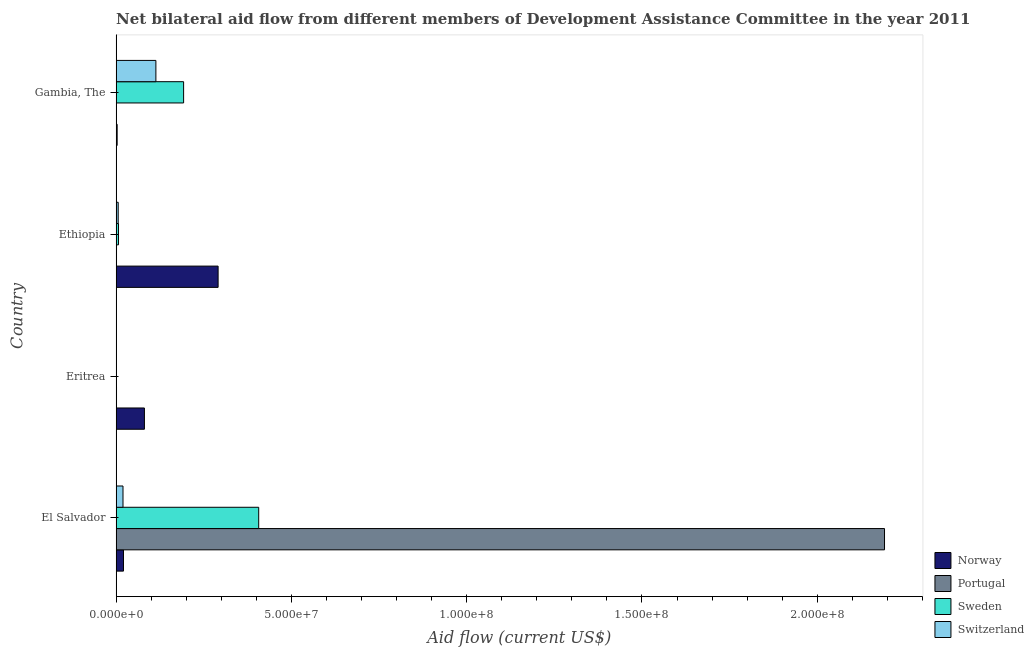Are the number of bars on each tick of the Y-axis equal?
Your response must be concise. Yes. How many bars are there on the 3rd tick from the top?
Offer a terse response. 4. How many bars are there on the 2nd tick from the bottom?
Offer a terse response. 4. What is the label of the 3rd group of bars from the top?
Offer a terse response. Eritrea. In how many cases, is the number of bars for a given country not equal to the number of legend labels?
Offer a terse response. 0. What is the amount of aid given by sweden in El Salvador?
Make the answer very short. 4.07e+07. Across all countries, what is the maximum amount of aid given by sweden?
Give a very brief answer. 4.07e+07. Across all countries, what is the minimum amount of aid given by switzerland?
Your answer should be very brief. 6.00e+04. In which country was the amount of aid given by switzerland maximum?
Offer a terse response. Gambia, The. In which country was the amount of aid given by switzerland minimum?
Your response must be concise. Eritrea. What is the total amount of aid given by norway in the graph?
Your answer should be compact. 3.96e+07. What is the difference between the amount of aid given by sweden in El Salvador and that in Gambia, The?
Provide a short and direct response. 2.14e+07. What is the difference between the amount of aid given by norway in Eritrea and the amount of aid given by portugal in El Salvador?
Offer a terse response. -2.11e+08. What is the average amount of aid given by switzerland per country?
Provide a succinct answer. 3.49e+06. What is the difference between the amount of aid given by sweden and amount of aid given by portugal in Ethiopia?
Your response must be concise. 5.70e+05. In how many countries, is the amount of aid given by portugal greater than 20000000 US$?
Provide a succinct answer. 1. What is the ratio of the amount of aid given by sweden in Eritrea to that in Gambia, The?
Offer a very short reply. 0. What is the difference between the highest and the second highest amount of aid given by switzerland?
Provide a succinct answer. 9.38e+06. What is the difference between the highest and the lowest amount of aid given by portugal?
Offer a terse response. 2.19e+08. In how many countries, is the amount of aid given by portugal greater than the average amount of aid given by portugal taken over all countries?
Offer a terse response. 1. Is the sum of the amount of aid given by portugal in Eritrea and Ethiopia greater than the maximum amount of aid given by switzerland across all countries?
Offer a very short reply. No. Is it the case that in every country, the sum of the amount of aid given by norway and amount of aid given by portugal is greater than the sum of amount of aid given by switzerland and amount of aid given by sweden?
Your answer should be compact. No. What does the 2nd bar from the bottom in El Salvador represents?
Ensure brevity in your answer.  Portugal. Is it the case that in every country, the sum of the amount of aid given by norway and amount of aid given by portugal is greater than the amount of aid given by sweden?
Keep it short and to the point. No. How many bars are there?
Your response must be concise. 16. Are all the bars in the graph horizontal?
Your response must be concise. Yes. Are the values on the major ticks of X-axis written in scientific E-notation?
Make the answer very short. Yes. Does the graph contain any zero values?
Offer a very short reply. No. Does the graph contain grids?
Offer a terse response. No. How many legend labels are there?
Your answer should be very brief. 4. How are the legend labels stacked?
Ensure brevity in your answer.  Vertical. What is the title of the graph?
Ensure brevity in your answer.  Net bilateral aid flow from different members of Development Assistance Committee in the year 2011. Does "Revenue mobilization" appear as one of the legend labels in the graph?
Your answer should be very brief. No. What is the label or title of the X-axis?
Provide a short and direct response. Aid flow (current US$). What is the label or title of the Y-axis?
Keep it short and to the point. Country. What is the Aid flow (current US$) in Norway in El Salvador?
Keep it short and to the point. 2.10e+06. What is the Aid flow (current US$) in Portugal in El Salvador?
Provide a short and direct response. 2.19e+08. What is the Aid flow (current US$) of Sweden in El Salvador?
Provide a succinct answer. 4.07e+07. What is the Aid flow (current US$) of Switzerland in El Salvador?
Provide a succinct answer. 1.96e+06. What is the Aid flow (current US$) of Norway in Eritrea?
Provide a succinct answer. 8.07e+06. What is the Aid flow (current US$) in Portugal in Eritrea?
Provide a short and direct response. 1.10e+05. What is the Aid flow (current US$) in Norway in Ethiopia?
Your response must be concise. 2.91e+07. What is the Aid flow (current US$) in Portugal in Ethiopia?
Your response must be concise. 1.10e+05. What is the Aid flow (current US$) in Sweden in Ethiopia?
Give a very brief answer. 6.80e+05. What is the Aid flow (current US$) in Switzerland in Ethiopia?
Offer a very short reply. 5.90e+05. What is the Aid flow (current US$) of Portugal in Gambia, The?
Your response must be concise. 2.00e+04. What is the Aid flow (current US$) of Sweden in Gambia, The?
Provide a short and direct response. 1.92e+07. What is the Aid flow (current US$) of Switzerland in Gambia, The?
Offer a terse response. 1.13e+07. Across all countries, what is the maximum Aid flow (current US$) of Norway?
Keep it short and to the point. 2.91e+07. Across all countries, what is the maximum Aid flow (current US$) of Portugal?
Your response must be concise. 2.19e+08. Across all countries, what is the maximum Aid flow (current US$) in Sweden?
Offer a terse response. 4.07e+07. Across all countries, what is the maximum Aid flow (current US$) in Switzerland?
Keep it short and to the point. 1.13e+07. Across all countries, what is the minimum Aid flow (current US$) of Sweden?
Ensure brevity in your answer.  6.00e+04. Across all countries, what is the minimum Aid flow (current US$) in Switzerland?
Offer a very short reply. 6.00e+04. What is the total Aid flow (current US$) of Norway in the graph?
Ensure brevity in your answer.  3.96e+07. What is the total Aid flow (current US$) in Portugal in the graph?
Provide a succinct answer. 2.19e+08. What is the total Aid flow (current US$) of Sweden in the graph?
Your response must be concise. 6.07e+07. What is the total Aid flow (current US$) in Switzerland in the graph?
Your answer should be compact. 1.40e+07. What is the difference between the Aid flow (current US$) of Norway in El Salvador and that in Eritrea?
Your response must be concise. -5.97e+06. What is the difference between the Aid flow (current US$) in Portugal in El Salvador and that in Eritrea?
Make the answer very short. 2.19e+08. What is the difference between the Aid flow (current US$) in Sweden in El Salvador and that in Eritrea?
Offer a terse response. 4.06e+07. What is the difference between the Aid flow (current US$) in Switzerland in El Salvador and that in Eritrea?
Make the answer very short. 1.90e+06. What is the difference between the Aid flow (current US$) of Norway in El Salvador and that in Ethiopia?
Provide a short and direct response. -2.70e+07. What is the difference between the Aid flow (current US$) in Portugal in El Salvador and that in Ethiopia?
Offer a very short reply. 2.19e+08. What is the difference between the Aid flow (current US$) of Sweden in El Salvador and that in Ethiopia?
Offer a terse response. 4.00e+07. What is the difference between the Aid flow (current US$) in Switzerland in El Salvador and that in Ethiopia?
Your answer should be very brief. 1.37e+06. What is the difference between the Aid flow (current US$) in Norway in El Salvador and that in Gambia, The?
Offer a very short reply. 1.81e+06. What is the difference between the Aid flow (current US$) in Portugal in El Salvador and that in Gambia, The?
Your answer should be compact. 2.19e+08. What is the difference between the Aid flow (current US$) in Sweden in El Salvador and that in Gambia, The?
Offer a terse response. 2.14e+07. What is the difference between the Aid flow (current US$) of Switzerland in El Salvador and that in Gambia, The?
Provide a succinct answer. -9.38e+06. What is the difference between the Aid flow (current US$) in Norway in Eritrea and that in Ethiopia?
Keep it short and to the point. -2.10e+07. What is the difference between the Aid flow (current US$) in Sweden in Eritrea and that in Ethiopia?
Provide a short and direct response. -6.20e+05. What is the difference between the Aid flow (current US$) in Switzerland in Eritrea and that in Ethiopia?
Your answer should be very brief. -5.30e+05. What is the difference between the Aid flow (current US$) in Norway in Eritrea and that in Gambia, The?
Give a very brief answer. 7.78e+06. What is the difference between the Aid flow (current US$) in Portugal in Eritrea and that in Gambia, The?
Provide a short and direct response. 9.00e+04. What is the difference between the Aid flow (current US$) in Sweden in Eritrea and that in Gambia, The?
Provide a succinct answer. -1.92e+07. What is the difference between the Aid flow (current US$) in Switzerland in Eritrea and that in Gambia, The?
Your answer should be compact. -1.13e+07. What is the difference between the Aid flow (current US$) in Norway in Ethiopia and that in Gambia, The?
Give a very brief answer. 2.88e+07. What is the difference between the Aid flow (current US$) in Portugal in Ethiopia and that in Gambia, The?
Your answer should be very brief. 9.00e+04. What is the difference between the Aid flow (current US$) in Sweden in Ethiopia and that in Gambia, The?
Your response must be concise. -1.86e+07. What is the difference between the Aid flow (current US$) of Switzerland in Ethiopia and that in Gambia, The?
Provide a short and direct response. -1.08e+07. What is the difference between the Aid flow (current US$) in Norway in El Salvador and the Aid flow (current US$) in Portugal in Eritrea?
Offer a terse response. 1.99e+06. What is the difference between the Aid flow (current US$) of Norway in El Salvador and the Aid flow (current US$) of Sweden in Eritrea?
Keep it short and to the point. 2.04e+06. What is the difference between the Aid flow (current US$) of Norway in El Salvador and the Aid flow (current US$) of Switzerland in Eritrea?
Make the answer very short. 2.04e+06. What is the difference between the Aid flow (current US$) of Portugal in El Salvador and the Aid flow (current US$) of Sweden in Eritrea?
Your answer should be compact. 2.19e+08. What is the difference between the Aid flow (current US$) in Portugal in El Salvador and the Aid flow (current US$) in Switzerland in Eritrea?
Keep it short and to the point. 2.19e+08. What is the difference between the Aid flow (current US$) in Sweden in El Salvador and the Aid flow (current US$) in Switzerland in Eritrea?
Provide a short and direct response. 4.06e+07. What is the difference between the Aid flow (current US$) in Norway in El Salvador and the Aid flow (current US$) in Portugal in Ethiopia?
Ensure brevity in your answer.  1.99e+06. What is the difference between the Aid flow (current US$) in Norway in El Salvador and the Aid flow (current US$) in Sweden in Ethiopia?
Make the answer very short. 1.42e+06. What is the difference between the Aid flow (current US$) in Norway in El Salvador and the Aid flow (current US$) in Switzerland in Ethiopia?
Offer a very short reply. 1.51e+06. What is the difference between the Aid flow (current US$) of Portugal in El Salvador and the Aid flow (current US$) of Sweden in Ethiopia?
Give a very brief answer. 2.19e+08. What is the difference between the Aid flow (current US$) of Portugal in El Salvador and the Aid flow (current US$) of Switzerland in Ethiopia?
Provide a succinct answer. 2.19e+08. What is the difference between the Aid flow (current US$) in Sweden in El Salvador and the Aid flow (current US$) in Switzerland in Ethiopia?
Provide a short and direct response. 4.01e+07. What is the difference between the Aid flow (current US$) in Norway in El Salvador and the Aid flow (current US$) in Portugal in Gambia, The?
Your response must be concise. 2.08e+06. What is the difference between the Aid flow (current US$) of Norway in El Salvador and the Aid flow (current US$) of Sweden in Gambia, The?
Provide a succinct answer. -1.72e+07. What is the difference between the Aid flow (current US$) of Norway in El Salvador and the Aid flow (current US$) of Switzerland in Gambia, The?
Offer a very short reply. -9.24e+06. What is the difference between the Aid flow (current US$) in Portugal in El Salvador and the Aid flow (current US$) in Sweden in Gambia, The?
Offer a very short reply. 2.00e+08. What is the difference between the Aid flow (current US$) of Portugal in El Salvador and the Aid flow (current US$) of Switzerland in Gambia, The?
Keep it short and to the point. 2.08e+08. What is the difference between the Aid flow (current US$) of Sweden in El Salvador and the Aid flow (current US$) of Switzerland in Gambia, The?
Keep it short and to the point. 2.93e+07. What is the difference between the Aid flow (current US$) in Norway in Eritrea and the Aid flow (current US$) in Portugal in Ethiopia?
Your response must be concise. 7.96e+06. What is the difference between the Aid flow (current US$) of Norway in Eritrea and the Aid flow (current US$) of Sweden in Ethiopia?
Ensure brevity in your answer.  7.39e+06. What is the difference between the Aid flow (current US$) of Norway in Eritrea and the Aid flow (current US$) of Switzerland in Ethiopia?
Offer a terse response. 7.48e+06. What is the difference between the Aid flow (current US$) in Portugal in Eritrea and the Aid flow (current US$) in Sweden in Ethiopia?
Give a very brief answer. -5.70e+05. What is the difference between the Aid flow (current US$) in Portugal in Eritrea and the Aid flow (current US$) in Switzerland in Ethiopia?
Ensure brevity in your answer.  -4.80e+05. What is the difference between the Aid flow (current US$) of Sweden in Eritrea and the Aid flow (current US$) of Switzerland in Ethiopia?
Offer a very short reply. -5.30e+05. What is the difference between the Aid flow (current US$) of Norway in Eritrea and the Aid flow (current US$) of Portugal in Gambia, The?
Make the answer very short. 8.05e+06. What is the difference between the Aid flow (current US$) in Norway in Eritrea and the Aid flow (current US$) in Sweden in Gambia, The?
Keep it short and to the point. -1.12e+07. What is the difference between the Aid flow (current US$) in Norway in Eritrea and the Aid flow (current US$) in Switzerland in Gambia, The?
Provide a succinct answer. -3.27e+06. What is the difference between the Aid flow (current US$) of Portugal in Eritrea and the Aid flow (current US$) of Sweden in Gambia, The?
Offer a very short reply. -1.91e+07. What is the difference between the Aid flow (current US$) in Portugal in Eritrea and the Aid flow (current US$) in Switzerland in Gambia, The?
Offer a very short reply. -1.12e+07. What is the difference between the Aid flow (current US$) of Sweden in Eritrea and the Aid flow (current US$) of Switzerland in Gambia, The?
Your response must be concise. -1.13e+07. What is the difference between the Aid flow (current US$) of Norway in Ethiopia and the Aid flow (current US$) of Portugal in Gambia, The?
Give a very brief answer. 2.91e+07. What is the difference between the Aid flow (current US$) of Norway in Ethiopia and the Aid flow (current US$) of Sweden in Gambia, The?
Ensure brevity in your answer.  9.84e+06. What is the difference between the Aid flow (current US$) in Norway in Ethiopia and the Aid flow (current US$) in Switzerland in Gambia, The?
Provide a succinct answer. 1.78e+07. What is the difference between the Aid flow (current US$) in Portugal in Ethiopia and the Aid flow (current US$) in Sweden in Gambia, The?
Make the answer very short. -1.91e+07. What is the difference between the Aid flow (current US$) of Portugal in Ethiopia and the Aid flow (current US$) of Switzerland in Gambia, The?
Your answer should be compact. -1.12e+07. What is the difference between the Aid flow (current US$) in Sweden in Ethiopia and the Aid flow (current US$) in Switzerland in Gambia, The?
Provide a succinct answer. -1.07e+07. What is the average Aid flow (current US$) of Norway per country?
Offer a terse response. 9.89e+06. What is the average Aid flow (current US$) of Portugal per country?
Provide a short and direct response. 5.49e+07. What is the average Aid flow (current US$) of Sweden per country?
Offer a very short reply. 1.52e+07. What is the average Aid flow (current US$) of Switzerland per country?
Your response must be concise. 3.49e+06. What is the difference between the Aid flow (current US$) of Norway and Aid flow (current US$) of Portugal in El Salvador?
Your answer should be compact. -2.17e+08. What is the difference between the Aid flow (current US$) in Norway and Aid flow (current US$) in Sweden in El Salvador?
Provide a succinct answer. -3.86e+07. What is the difference between the Aid flow (current US$) in Portugal and Aid flow (current US$) in Sweden in El Salvador?
Offer a very short reply. 1.79e+08. What is the difference between the Aid flow (current US$) in Portugal and Aid flow (current US$) in Switzerland in El Salvador?
Your response must be concise. 2.17e+08. What is the difference between the Aid flow (current US$) of Sweden and Aid flow (current US$) of Switzerland in El Salvador?
Give a very brief answer. 3.87e+07. What is the difference between the Aid flow (current US$) in Norway and Aid flow (current US$) in Portugal in Eritrea?
Offer a terse response. 7.96e+06. What is the difference between the Aid flow (current US$) of Norway and Aid flow (current US$) of Sweden in Eritrea?
Provide a succinct answer. 8.01e+06. What is the difference between the Aid flow (current US$) in Norway and Aid flow (current US$) in Switzerland in Eritrea?
Your response must be concise. 8.01e+06. What is the difference between the Aid flow (current US$) of Portugal and Aid flow (current US$) of Sweden in Eritrea?
Give a very brief answer. 5.00e+04. What is the difference between the Aid flow (current US$) in Portugal and Aid flow (current US$) in Switzerland in Eritrea?
Make the answer very short. 5.00e+04. What is the difference between the Aid flow (current US$) in Norway and Aid flow (current US$) in Portugal in Ethiopia?
Your answer should be very brief. 2.90e+07. What is the difference between the Aid flow (current US$) of Norway and Aid flow (current US$) of Sweden in Ethiopia?
Offer a very short reply. 2.84e+07. What is the difference between the Aid flow (current US$) in Norway and Aid flow (current US$) in Switzerland in Ethiopia?
Your answer should be very brief. 2.85e+07. What is the difference between the Aid flow (current US$) in Portugal and Aid flow (current US$) in Sweden in Ethiopia?
Ensure brevity in your answer.  -5.70e+05. What is the difference between the Aid flow (current US$) in Portugal and Aid flow (current US$) in Switzerland in Ethiopia?
Ensure brevity in your answer.  -4.80e+05. What is the difference between the Aid flow (current US$) in Norway and Aid flow (current US$) in Portugal in Gambia, The?
Offer a very short reply. 2.70e+05. What is the difference between the Aid flow (current US$) of Norway and Aid flow (current US$) of Sweden in Gambia, The?
Offer a very short reply. -1.90e+07. What is the difference between the Aid flow (current US$) in Norway and Aid flow (current US$) in Switzerland in Gambia, The?
Offer a terse response. -1.10e+07. What is the difference between the Aid flow (current US$) in Portugal and Aid flow (current US$) in Sweden in Gambia, The?
Your answer should be compact. -1.92e+07. What is the difference between the Aid flow (current US$) in Portugal and Aid flow (current US$) in Switzerland in Gambia, The?
Give a very brief answer. -1.13e+07. What is the difference between the Aid flow (current US$) in Sweden and Aid flow (current US$) in Switzerland in Gambia, The?
Make the answer very short. 7.91e+06. What is the ratio of the Aid flow (current US$) in Norway in El Salvador to that in Eritrea?
Provide a succinct answer. 0.26. What is the ratio of the Aid flow (current US$) of Portugal in El Salvador to that in Eritrea?
Provide a short and direct response. 1992.64. What is the ratio of the Aid flow (current US$) in Sweden in El Salvador to that in Eritrea?
Ensure brevity in your answer.  677.83. What is the ratio of the Aid flow (current US$) in Switzerland in El Salvador to that in Eritrea?
Your response must be concise. 32.67. What is the ratio of the Aid flow (current US$) of Norway in El Salvador to that in Ethiopia?
Provide a succinct answer. 0.07. What is the ratio of the Aid flow (current US$) of Portugal in El Salvador to that in Ethiopia?
Your response must be concise. 1992.64. What is the ratio of the Aid flow (current US$) of Sweden in El Salvador to that in Ethiopia?
Offer a very short reply. 59.81. What is the ratio of the Aid flow (current US$) of Switzerland in El Salvador to that in Ethiopia?
Your answer should be compact. 3.32. What is the ratio of the Aid flow (current US$) in Norway in El Salvador to that in Gambia, The?
Your answer should be very brief. 7.24. What is the ratio of the Aid flow (current US$) in Portugal in El Salvador to that in Gambia, The?
Ensure brevity in your answer.  1.10e+04. What is the ratio of the Aid flow (current US$) of Sweden in El Salvador to that in Gambia, The?
Give a very brief answer. 2.11. What is the ratio of the Aid flow (current US$) in Switzerland in El Salvador to that in Gambia, The?
Ensure brevity in your answer.  0.17. What is the ratio of the Aid flow (current US$) of Norway in Eritrea to that in Ethiopia?
Ensure brevity in your answer.  0.28. What is the ratio of the Aid flow (current US$) of Portugal in Eritrea to that in Ethiopia?
Offer a terse response. 1. What is the ratio of the Aid flow (current US$) of Sweden in Eritrea to that in Ethiopia?
Your answer should be very brief. 0.09. What is the ratio of the Aid flow (current US$) of Switzerland in Eritrea to that in Ethiopia?
Make the answer very short. 0.1. What is the ratio of the Aid flow (current US$) in Norway in Eritrea to that in Gambia, The?
Offer a terse response. 27.83. What is the ratio of the Aid flow (current US$) of Portugal in Eritrea to that in Gambia, The?
Give a very brief answer. 5.5. What is the ratio of the Aid flow (current US$) of Sweden in Eritrea to that in Gambia, The?
Keep it short and to the point. 0. What is the ratio of the Aid flow (current US$) of Switzerland in Eritrea to that in Gambia, The?
Your response must be concise. 0.01. What is the ratio of the Aid flow (current US$) in Norway in Ethiopia to that in Gambia, The?
Your answer should be compact. 100.31. What is the ratio of the Aid flow (current US$) of Portugal in Ethiopia to that in Gambia, The?
Make the answer very short. 5.5. What is the ratio of the Aid flow (current US$) of Sweden in Ethiopia to that in Gambia, The?
Provide a succinct answer. 0.04. What is the ratio of the Aid flow (current US$) in Switzerland in Ethiopia to that in Gambia, The?
Your answer should be very brief. 0.05. What is the difference between the highest and the second highest Aid flow (current US$) of Norway?
Give a very brief answer. 2.10e+07. What is the difference between the highest and the second highest Aid flow (current US$) in Portugal?
Keep it short and to the point. 2.19e+08. What is the difference between the highest and the second highest Aid flow (current US$) of Sweden?
Give a very brief answer. 2.14e+07. What is the difference between the highest and the second highest Aid flow (current US$) of Switzerland?
Your answer should be very brief. 9.38e+06. What is the difference between the highest and the lowest Aid flow (current US$) of Norway?
Your answer should be compact. 2.88e+07. What is the difference between the highest and the lowest Aid flow (current US$) of Portugal?
Ensure brevity in your answer.  2.19e+08. What is the difference between the highest and the lowest Aid flow (current US$) of Sweden?
Your response must be concise. 4.06e+07. What is the difference between the highest and the lowest Aid flow (current US$) in Switzerland?
Ensure brevity in your answer.  1.13e+07. 